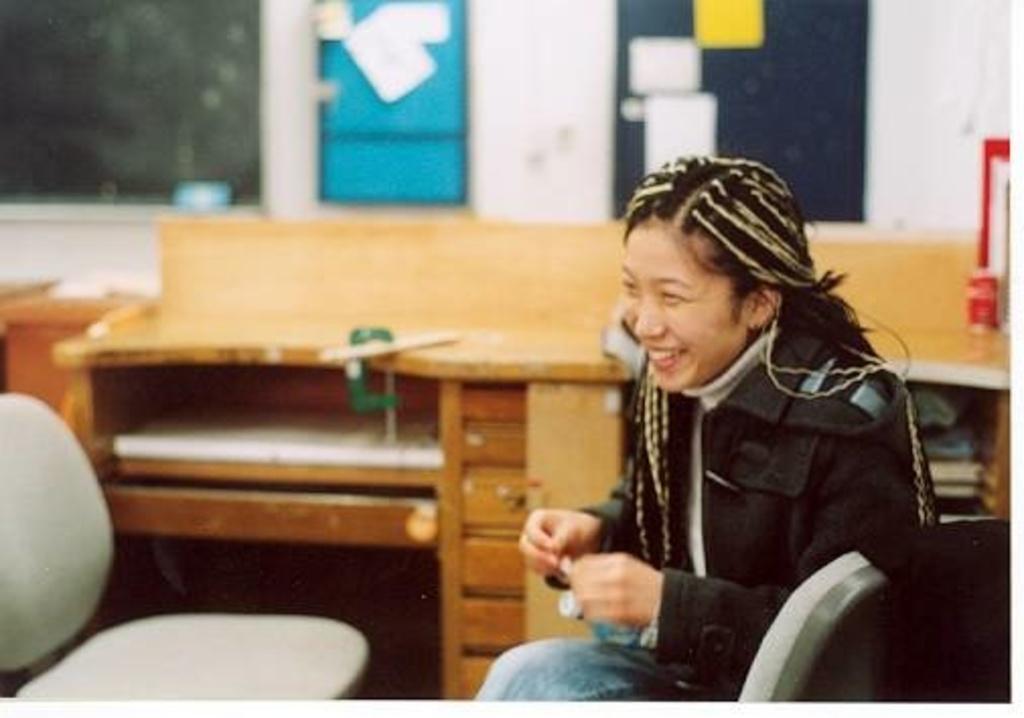Could you give a brief overview of what you see in this image? In this image there is a girl sitting on a chair with a smile on her face and she is looking to the right side of the image, beside her there is an empty chair, behind her there is a cupboard with some objects in it. In the background there are few boards and papers hanging on the wall. 